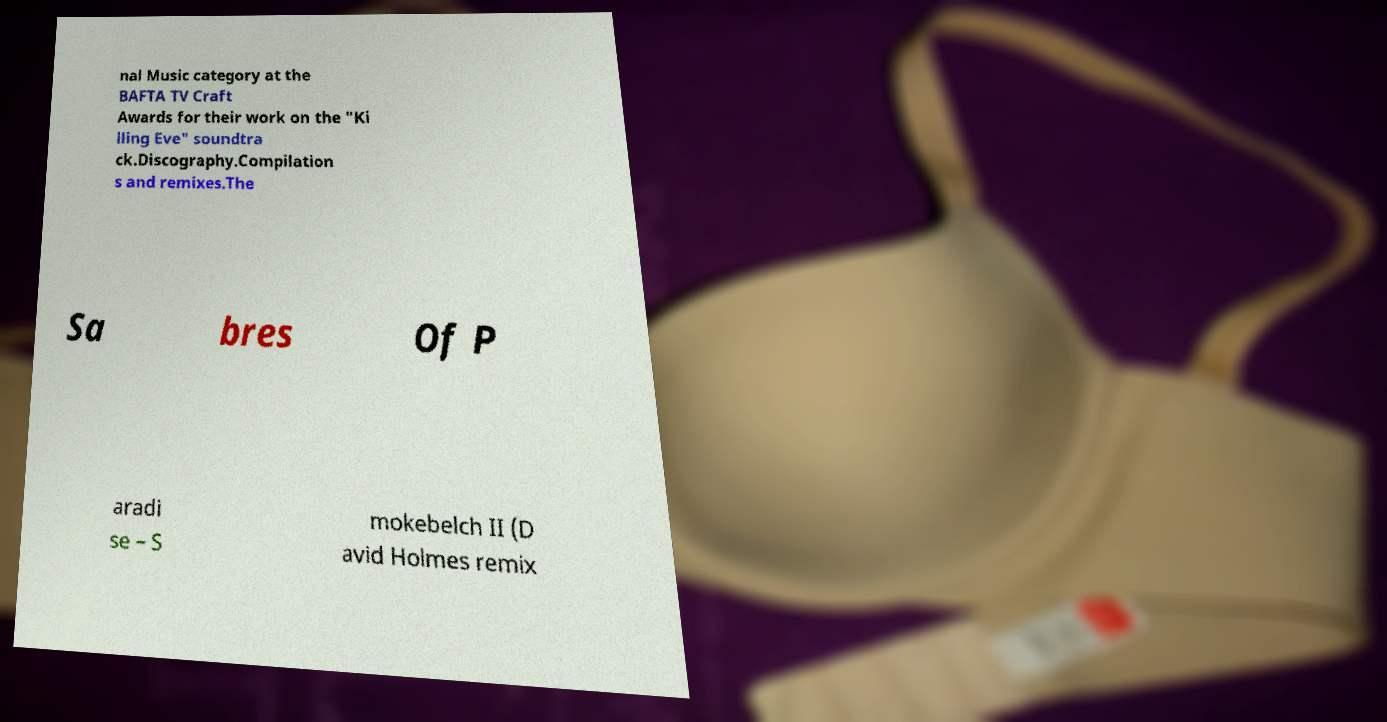Please read and relay the text visible in this image. What does it say? nal Music category at the BAFTA TV Craft Awards for their work on the "Ki lling Eve" soundtra ck.Discography.Compilation s and remixes.The Sa bres Of P aradi se – S mokebelch II (D avid Holmes remix 